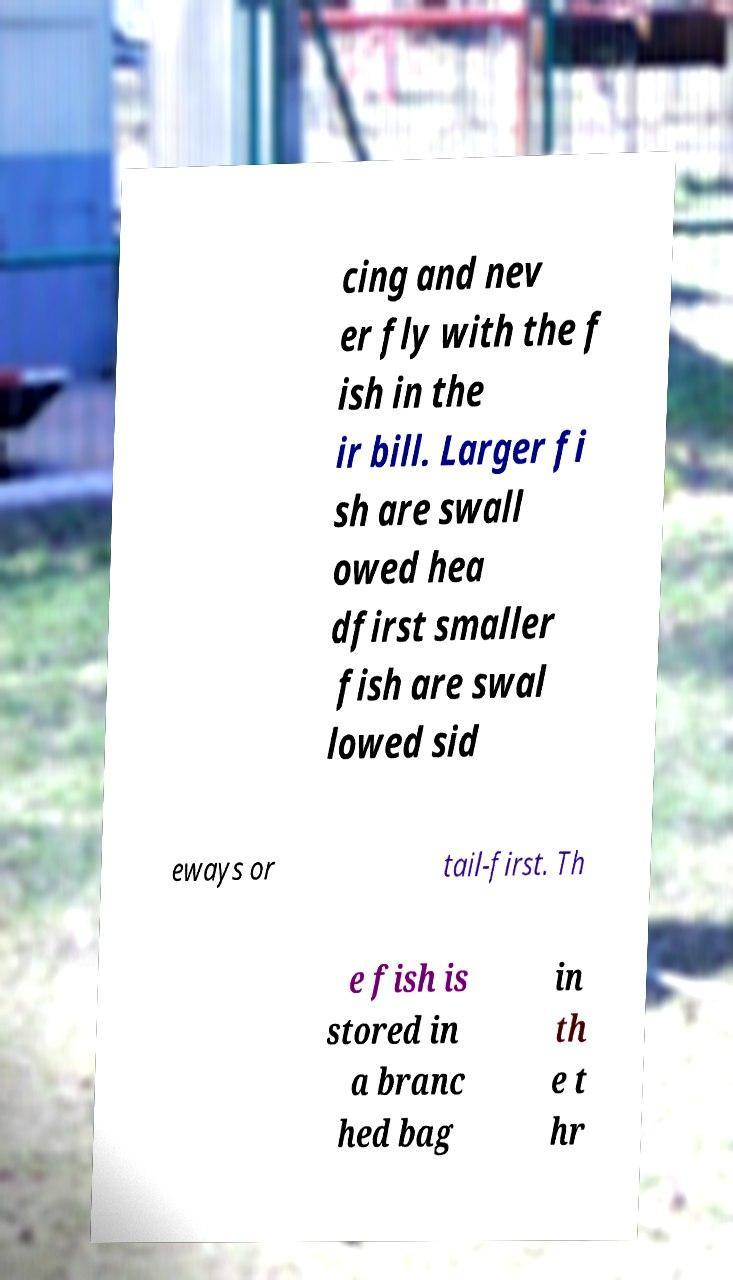What messages or text are displayed in this image? I need them in a readable, typed format. cing and nev er fly with the f ish in the ir bill. Larger fi sh are swall owed hea dfirst smaller fish are swal lowed sid eways or tail-first. Th e fish is stored in a branc hed bag in th e t hr 